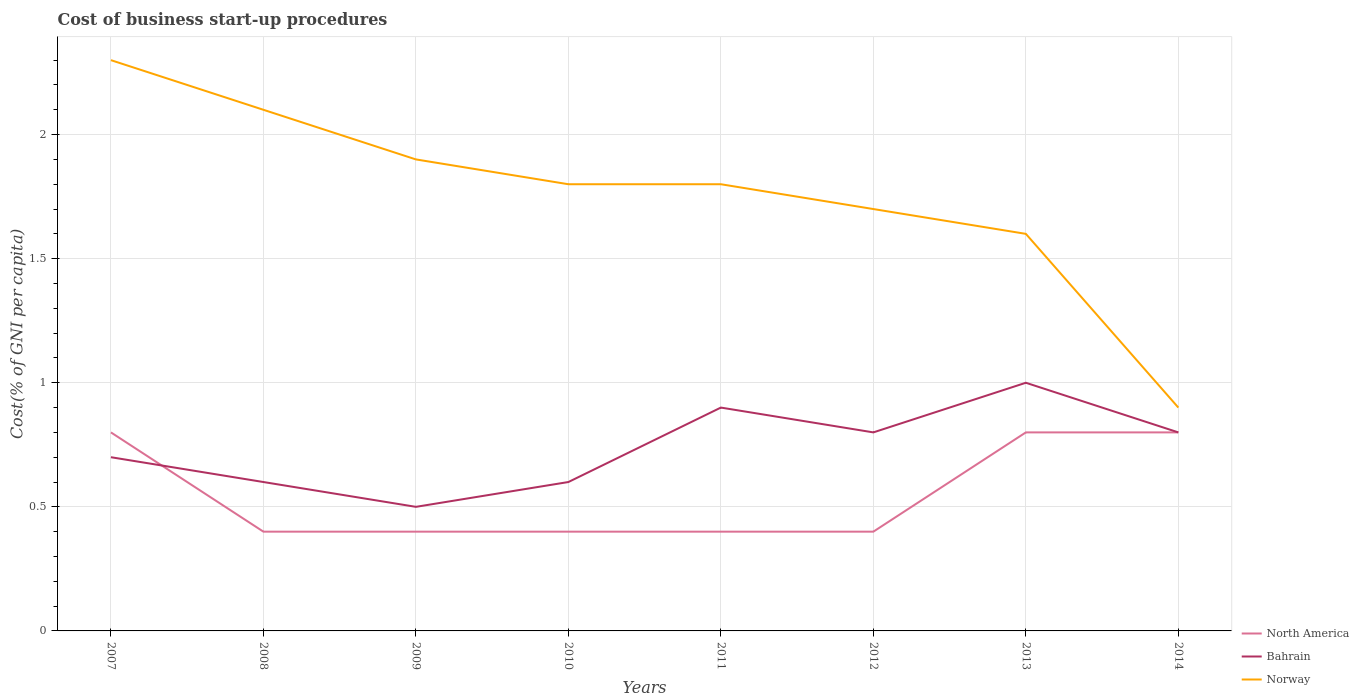Does the line corresponding to Bahrain intersect with the line corresponding to Norway?
Keep it short and to the point. No. What is the total cost of business start-up procedures in Norway in the graph?
Keep it short and to the point. 0.1. What is the difference between the highest and the second highest cost of business start-up procedures in North America?
Ensure brevity in your answer.  0.4. What is the difference between two consecutive major ticks on the Y-axis?
Offer a terse response. 0.5. Does the graph contain grids?
Make the answer very short. Yes. What is the title of the graph?
Offer a terse response. Cost of business start-up procedures. Does "Myanmar" appear as one of the legend labels in the graph?
Your answer should be very brief. No. What is the label or title of the Y-axis?
Offer a terse response. Cost(% of GNI per capita). What is the Cost(% of GNI per capita) in Bahrain in 2007?
Give a very brief answer. 0.7. What is the Cost(% of GNI per capita) in Norway in 2008?
Offer a very short reply. 2.1. What is the Cost(% of GNI per capita) of North America in 2009?
Ensure brevity in your answer.  0.4. What is the Cost(% of GNI per capita) of North America in 2010?
Your answer should be very brief. 0.4. What is the Cost(% of GNI per capita) in Norway in 2010?
Offer a terse response. 1.8. What is the Cost(% of GNI per capita) in North America in 2011?
Offer a very short reply. 0.4. What is the Cost(% of GNI per capita) in Bahrain in 2011?
Offer a very short reply. 0.9. What is the Cost(% of GNI per capita) in Norway in 2012?
Offer a very short reply. 1.7. What is the Cost(% of GNI per capita) of North America in 2013?
Give a very brief answer. 0.8. What is the Cost(% of GNI per capita) in Bahrain in 2013?
Make the answer very short. 1. What is the Cost(% of GNI per capita) of Norway in 2013?
Offer a very short reply. 1.6. What is the Cost(% of GNI per capita) in North America in 2014?
Keep it short and to the point. 0.8. What is the Cost(% of GNI per capita) in Norway in 2014?
Your response must be concise. 0.9. Across all years, what is the maximum Cost(% of GNI per capita) of North America?
Your answer should be compact. 0.8. Across all years, what is the maximum Cost(% of GNI per capita) of Bahrain?
Offer a terse response. 1. Across all years, what is the maximum Cost(% of GNI per capita) of Norway?
Offer a very short reply. 2.3. Across all years, what is the minimum Cost(% of GNI per capita) of Bahrain?
Make the answer very short. 0.5. What is the total Cost(% of GNI per capita) in North America in the graph?
Ensure brevity in your answer.  4.4. What is the total Cost(% of GNI per capita) in Norway in the graph?
Provide a short and direct response. 14.1. What is the difference between the Cost(% of GNI per capita) of Bahrain in 2007 and that in 2009?
Your answer should be very brief. 0.2. What is the difference between the Cost(% of GNI per capita) in Bahrain in 2007 and that in 2010?
Your response must be concise. 0.1. What is the difference between the Cost(% of GNI per capita) of Norway in 2007 and that in 2010?
Keep it short and to the point. 0.5. What is the difference between the Cost(% of GNI per capita) in North America in 2007 and that in 2011?
Give a very brief answer. 0.4. What is the difference between the Cost(% of GNI per capita) in Bahrain in 2007 and that in 2012?
Provide a succinct answer. -0.1. What is the difference between the Cost(% of GNI per capita) of North America in 2007 and that in 2013?
Offer a terse response. 0. What is the difference between the Cost(% of GNI per capita) in Bahrain in 2007 and that in 2013?
Make the answer very short. -0.3. What is the difference between the Cost(% of GNI per capita) of Norway in 2007 and that in 2013?
Provide a succinct answer. 0.7. What is the difference between the Cost(% of GNI per capita) of North America in 2007 and that in 2014?
Offer a very short reply. 0. What is the difference between the Cost(% of GNI per capita) of Norway in 2008 and that in 2009?
Keep it short and to the point. 0.2. What is the difference between the Cost(% of GNI per capita) in Bahrain in 2008 and that in 2010?
Your response must be concise. 0. What is the difference between the Cost(% of GNI per capita) of North America in 2008 and that in 2011?
Give a very brief answer. 0. What is the difference between the Cost(% of GNI per capita) in Bahrain in 2008 and that in 2011?
Offer a terse response. -0.3. What is the difference between the Cost(% of GNI per capita) of North America in 2008 and that in 2012?
Your response must be concise. 0. What is the difference between the Cost(% of GNI per capita) in Bahrain in 2008 and that in 2012?
Provide a succinct answer. -0.2. What is the difference between the Cost(% of GNI per capita) in North America in 2008 and that in 2013?
Ensure brevity in your answer.  -0.4. What is the difference between the Cost(% of GNI per capita) of Norway in 2008 and that in 2014?
Make the answer very short. 1.2. What is the difference between the Cost(% of GNI per capita) in North America in 2009 and that in 2010?
Your response must be concise. 0. What is the difference between the Cost(% of GNI per capita) of North America in 2009 and that in 2011?
Offer a very short reply. 0. What is the difference between the Cost(% of GNI per capita) of North America in 2009 and that in 2012?
Your answer should be compact. 0. What is the difference between the Cost(% of GNI per capita) of Norway in 2009 and that in 2012?
Ensure brevity in your answer.  0.2. What is the difference between the Cost(% of GNI per capita) of Norway in 2009 and that in 2013?
Provide a succinct answer. 0.3. What is the difference between the Cost(% of GNI per capita) of North America in 2009 and that in 2014?
Your response must be concise. -0.4. What is the difference between the Cost(% of GNI per capita) in Bahrain in 2009 and that in 2014?
Your answer should be compact. -0.3. What is the difference between the Cost(% of GNI per capita) in North America in 2010 and that in 2011?
Ensure brevity in your answer.  0. What is the difference between the Cost(% of GNI per capita) in Bahrain in 2010 and that in 2011?
Offer a terse response. -0.3. What is the difference between the Cost(% of GNI per capita) of North America in 2010 and that in 2012?
Ensure brevity in your answer.  0. What is the difference between the Cost(% of GNI per capita) in Bahrain in 2010 and that in 2012?
Your answer should be very brief. -0.2. What is the difference between the Cost(% of GNI per capita) of North America in 2010 and that in 2013?
Offer a very short reply. -0.4. What is the difference between the Cost(% of GNI per capita) of Norway in 2010 and that in 2013?
Your response must be concise. 0.2. What is the difference between the Cost(% of GNI per capita) in North America in 2010 and that in 2014?
Keep it short and to the point. -0.4. What is the difference between the Cost(% of GNI per capita) in Bahrain in 2010 and that in 2014?
Your response must be concise. -0.2. What is the difference between the Cost(% of GNI per capita) in North America in 2011 and that in 2012?
Your response must be concise. 0. What is the difference between the Cost(% of GNI per capita) in Bahrain in 2011 and that in 2012?
Provide a short and direct response. 0.1. What is the difference between the Cost(% of GNI per capita) of Norway in 2011 and that in 2012?
Keep it short and to the point. 0.1. What is the difference between the Cost(% of GNI per capita) in North America in 2011 and that in 2013?
Offer a terse response. -0.4. What is the difference between the Cost(% of GNI per capita) of Bahrain in 2011 and that in 2013?
Make the answer very short. -0.1. What is the difference between the Cost(% of GNI per capita) of Norway in 2011 and that in 2013?
Your answer should be very brief. 0.2. What is the difference between the Cost(% of GNI per capita) in North America in 2011 and that in 2014?
Ensure brevity in your answer.  -0.4. What is the difference between the Cost(% of GNI per capita) of Bahrain in 2011 and that in 2014?
Make the answer very short. 0.1. What is the difference between the Cost(% of GNI per capita) of North America in 2012 and that in 2013?
Keep it short and to the point. -0.4. What is the difference between the Cost(% of GNI per capita) of Norway in 2012 and that in 2013?
Keep it short and to the point. 0.1. What is the difference between the Cost(% of GNI per capita) in Bahrain in 2012 and that in 2014?
Offer a terse response. 0. What is the difference between the Cost(% of GNI per capita) of Norway in 2012 and that in 2014?
Give a very brief answer. 0.8. What is the difference between the Cost(% of GNI per capita) in Norway in 2013 and that in 2014?
Your answer should be very brief. 0.7. What is the difference between the Cost(% of GNI per capita) in North America in 2007 and the Cost(% of GNI per capita) in Norway in 2008?
Your response must be concise. -1.3. What is the difference between the Cost(% of GNI per capita) of North America in 2007 and the Cost(% of GNI per capita) of Bahrain in 2009?
Provide a short and direct response. 0.3. What is the difference between the Cost(% of GNI per capita) of North America in 2007 and the Cost(% of GNI per capita) of Norway in 2009?
Make the answer very short. -1.1. What is the difference between the Cost(% of GNI per capita) in North America in 2007 and the Cost(% of GNI per capita) in Norway in 2011?
Offer a very short reply. -1. What is the difference between the Cost(% of GNI per capita) in North America in 2007 and the Cost(% of GNI per capita) in Bahrain in 2012?
Your answer should be compact. 0. What is the difference between the Cost(% of GNI per capita) of Bahrain in 2007 and the Cost(% of GNI per capita) of Norway in 2013?
Offer a terse response. -0.9. What is the difference between the Cost(% of GNI per capita) of North America in 2007 and the Cost(% of GNI per capita) of Bahrain in 2014?
Offer a very short reply. 0. What is the difference between the Cost(% of GNI per capita) in North America in 2008 and the Cost(% of GNI per capita) in Bahrain in 2009?
Your response must be concise. -0.1. What is the difference between the Cost(% of GNI per capita) of Bahrain in 2008 and the Cost(% of GNI per capita) of Norway in 2009?
Give a very brief answer. -1.3. What is the difference between the Cost(% of GNI per capita) of North America in 2008 and the Cost(% of GNI per capita) of Bahrain in 2012?
Provide a short and direct response. -0.4. What is the difference between the Cost(% of GNI per capita) in Bahrain in 2008 and the Cost(% of GNI per capita) in Norway in 2012?
Ensure brevity in your answer.  -1.1. What is the difference between the Cost(% of GNI per capita) in North America in 2008 and the Cost(% of GNI per capita) in Norway in 2013?
Offer a very short reply. -1.2. What is the difference between the Cost(% of GNI per capita) of Bahrain in 2008 and the Cost(% of GNI per capita) of Norway in 2014?
Offer a very short reply. -0.3. What is the difference between the Cost(% of GNI per capita) of North America in 2009 and the Cost(% of GNI per capita) of Bahrain in 2010?
Offer a terse response. -0.2. What is the difference between the Cost(% of GNI per capita) in North America in 2009 and the Cost(% of GNI per capita) in Norway in 2010?
Offer a terse response. -1.4. What is the difference between the Cost(% of GNI per capita) in North America in 2009 and the Cost(% of GNI per capita) in Bahrain in 2011?
Make the answer very short. -0.5. What is the difference between the Cost(% of GNI per capita) in North America in 2009 and the Cost(% of GNI per capita) in Norway in 2011?
Make the answer very short. -1.4. What is the difference between the Cost(% of GNI per capita) of Bahrain in 2009 and the Cost(% of GNI per capita) of Norway in 2011?
Offer a very short reply. -1.3. What is the difference between the Cost(% of GNI per capita) in Bahrain in 2009 and the Cost(% of GNI per capita) in Norway in 2012?
Provide a short and direct response. -1.2. What is the difference between the Cost(% of GNI per capita) in North America in 2009 and the Cost(% of GNI per capita) in Bahrain in 2013?
Your answer should be very brief. -0.6. What is the difference between the Cost(% of GNI per capita) in North America in 2009 and the Cost(% of GNI per capita) in Norway in 2013?
Offer a terse response. -1.2. What is the difference between the Cost(% of GNI per capita) in Bahrain in 2009 and the Cost(% of GNI per capita) in Norway in 2013?
Provide a succinct answer. -1.1. What is the difference between the Cost(% of GNI per capita) of North America in 2009 and the Cost(% of GNI per capita) of Bahrain in 2014?
Provide a short and direct response. -0.4. What is the difference between the Cost(% of GNI per capita) of Bahrain in 2009 and the Cost(% of GNI per capita) of Norway in 2014?
Keep it short and to the point. -0.4. What is the difference between the Cost(% of GNI per capita) of North America in 2010 and the Cost(% of GNI per capita) of Bahrain in 2011?
Your answer should be very brief. -0.5. What is the difference between the Cost(% of GNI per capita) in North America in 2010 and the Cost(% of GNI per capita) in Bahrain in 2013?
Offer a terse response. -0.6. What is the difference between the Cost(% of GNI per capita) of Bahrain in 2010 and the Cost(% of GNI per capita) of Norway in 2013?
Give a very brief answer. -1. What is the difference between the Cost(% of GNI per capita) of North America in 2010 and the Cost(% of GNI per capita) of Bahrain in 2014?
Keep it short and to the point. -0.4. What is the difference between the Cost(% of GNI per capita) of Bahrain in 2010 and the Cost(% of GNI per capita) of Norway in 2014?
Provide a short and direct response. -0.3. What is the difference between the Cost(% of GNI per capita) of North America in 2011 and the Cost(% of GNI per capita) of Bahrain in 2013?
Ensure brevity in your answer.  -0.6. What is the difference between the Cost(% of GNI per capita) of North America in 2011 and the Cost(% of GNI per capita) of Bahrain in 2014?
Offer a terse response. -0.4. What is the difference between the Cost(% of GNI per capita) in North America in 2012 and the Cost(% of GNI per capita) in Bahrain in 2013?
Provide a succinct answer. -0.6. What is the difference between the Cost(% of GNI per capita) of Bahrain in 2012 and the Cost(% of GNI per capita) of Norway in 2013?
Make the answer very short. -0.8. What is the difference between the Cost(% of GNI per capita) of North America in 2012 and the Cost(% of GNI per capita) of Bahrain in 2014?
Your answer should be very brief. -0.4. What is the difference between the Cost(% of GNI per capita) in North America in 2012 and the Cost(% of GNI per capita) in Norway in 2014?
Ensure brevity in your answer.  -0.5. What is the difference between the Cost(% of GNI per capita) in Bahrain in 2012 and the Cost(% of GNI per capita) in Norway in 2014?
Provide a succinct answer. -0.1. What is the difference between the Cost(% of GNI per capita) in North America in 2013 and the Cost(% of GNI per capita) in Norway in 2014?
Offer a terse response. -0.1. What is the average Cost(% of GNI per capita) in North America per year?
Give a very brief answer. 0.55. What is the average Cost(% of GNI per capita) of Bahrain per year?
Your response must be concise. 0.74. What is the average Cost(% of GNI per capita) in Norway per year?
Your answer should be very brief. 1.76. In the year 2007, what is the difference between the Cost(% of GNI per capita) in North America and Cost(% of GNI per capita) in Norway?
Make the answer very short. -1.5. In the year 2008, what is the difference between the Cost(% of GNI per capita) of North America and Cost(% of GNI per capita) of Bahrain?
Keep it short and to the point. -0.2. In the year 2008, what is the difference between the Cost(% of GNI per capita) of North America and Cost(% of GNI per capita) of Norway?
Give a very brief answer. -1.7. In the year 2008, what is the difference between the Cost(% of GNI per capita) of Bahrain and Cost(% of GNI per capita) of Norway?
Keep it short and to the point. -1.5. In the year 2009, what is the difference between the Cost(% of GNI per capita) in Bahrain and Cost(% of GNI per capita) in Norway?
Keep it short and to the point. -1.4. In the year 2010, what is the difference between the Cost(% of GNI per capita) of North America and Cost(% of GNI per capita) of Bahrain?
Offer a very short reply. -0.2. In the year 2010, what is the difference between the Cost(% of GNI per capita) of North America and Cost(% of GNI per capita) of Norway?
Give a very brief answer. -1.4. In the year 2011, what is the difference between the Cost(% of GNI per capita) of North America and Cost(% of GNI per capita) of Bahrain?
Your answer should be compact. -0.5. In the year 2011, what is the difference between the Cost(% of GNI per capita) in North America and Cost(% of GNI per capita) in Norway?
Give a very brief answer. -1.4. In the year 2011, what is the difference between the Cost(% of GNI per capita) in Bahrain and Cost(% of GNI per capita) in Norway?
Keep it short and to the point. -0.9. In the year 2012, what is the difference between the Cost(% of GNI per capita) of North America and Cost(% of GNI per capita) of Bahrain?
Give a very brief answer. -0.4. In the year 2014, what is the difference between the Cost(% of GNI per capita) of North America and Cost(% of GNI per capita) of Norway?
Offer a terse response. -0.1. In the year 2014, what is the difference between the Cost(% of GNI per capita) of Bahrain and Cost(% of GNI per capita) of Norway?
Provide a succinct answer. -0.1. What is the ratio of the Cost(% of GNI per capita) in Norway in 2007 to that in 2008?
Give a very brief answer. 1.1. What is the ratio of the Cost(% of GNI per capita) in North America in 2007 to that in 2009?
Give a very brief answer. 2. What is the ratio of the Cost(% of GNI per capita) of Norway in 2007 to that in 2009?
Your answer should be very brief. 1.21. What is the ratio of the Cost(% of GNI per capita) in North America in 2007 to that in 2010?
Provide a short and direct response. 2. What is the ratio of the Cost(% of GNI per capita) in Norway in 2007 to that in 2010?
Your answer should be very brief. 1.28. What is the ratio of the Cost(% of GNI per capita) in Norway in 2007 to that in 2011?
Make the answer very short. 1.28. What is the ratio of the Cost(% of GNI per capita) in Norway in 2007 to that in 2012?
Give a very brief answer. 1.35. What is the ratio of the Cost(% of GNI per capita) of North America in 2007 to that in 2013?
Ensure brevity in your answer.  1. What is the ratio of the Cost(% of GNI per capita) of Bahrain in 2007 to that in 2013?
Provide a short and direct response. 0.7. What is the ratio of the Cost(% of GNI per capita) in Norway in 2007 to that in 2013?
Keep it short and to the point. 1.44. What is the ratio of the Cost(% of GNI per capita) in Norway in 2007 to that in 2014?
Give a very brief answer. 2.56. What is the ratio of the Cost(% of GNI per capita) in North America in 2008 to that in 2009?
Ensure brevity in your answer.  1. What is the ratio of the Cost(% of GNI per capita) of Bahrain in 2008 to that in 2009?
Offer a terse response. 1.2. What is the ratio of the Cost(% of GNI per capita) of Norway in 2008 to that in 2009?
Provide a short and direct response. 1.11. What is the ratio of the Cost(% of GNI per capita) in North America in 2008 to that in 2010?
Keep it short and to the point. 1. What is the ratio of the Cost(% of GNI per capita) in Bahrain in 2008 to that in 2011?
Make the answer very short. 0.67. What is the ratio of the Cost(% of GNI per capita) of North America in 2008 to that in 2012?
Offer a terse response. 1. What is the ratio of the Cost(% of GNI per capita) in Norway in 2008 to that in 2012?
Keep it short and to the point. 1.24. What is the ratio of the Cost(% of GNI per capita) of North America in 2008 to that in 2013?
Your response must be concise. 0.5. What is the ratio of the Cost(% of GNI per capita) of Norway in 2008 to that in 2013?
Provide a succinct answer. 1.31. What is the ratio of the Cost(% of GNI per capita) in Norway in 2008 to that in 2014?
Provide a succinct answer. 2.33. What is the ratio of the Cost(% of GNI per capita) in North America in 2009 to that in 2010?
Ensure brevity in your answer.  1. What is the ratio of the Cost(% of GNI per capita) of Bahrain in 2009 to that in 2010?
Ensure brevity in your answer.  0.83. What is the ratio of the Cost(% of GNI per capita) in Norway in 2009 to that in 2010?
Provide a short and direct response. 1.06. What is the ratio of the Cost(% of GNI per capita) in North America in 2009 to that in 2011?
Provide a succinct answer. 1. What is the ratio of the Cost(% of GNI per capita) in Bahrain in 2009 to that in 2011?
Offer a terse response. 0.56. What is the ratio of the Cost(% of GNI per capita) of Norway in 2009 to that in 2011?
Offer a terse response. 1.06. What is the ratio of the Cost(% of GNI per capita) of Bahrain in 2009 to that in 2012?
Your response must be concise. 0.62. What is the ratio of the Cost(% of GNI per capita) in Norway in 2009 to that in 2012?
Keep it short and to the point. 1.12. What is the ratio of the Cost(% of GNI per capita) in North America in 2009 to that in 2013?
Provide a succinct answer. 0.5. What is the ratio of the Cost(% of GNI per capita) of Norway in 2009 to that in 2013?
Offer a terse response. 1.19. What is the ratio of the Cost(% of GNI per capita) in North America in 2009 to that in 2014?
Keep it short and to the point. 0.5. What is the ratio of the Cost(% of GNI per capita) of Bahrain in 2009 to that in 2014?
Your response must be concise. 0.62. What is the ratio of the Cost(% of GNI per capita) of Norway in 2009 to that in 2014?
Your answer should be very brief. 2.11. What is the ratio of the Cost(% of GNI per capita) of Norway in 2010 to that in 2012?
Your answer should be very brief. 1.06. What is the ratio of the Cost(% of GNI per capita) of Bahrain in 2011 to that in 2012?
Keep it short and to the point. 1.12. What is the ratio of the Cost(% of GNI per capita) of Norway in 2011 to that in 2012?
Offer a very short reply. 1.06. What is the ratio of the Cost(% of GNI per capita) of North America in 2011 to that in 2013?
Your answer should be very brief. 0.5. What is the ratio of the Cost(% of GNI per capita) in Bahrain in 2011 to that in 2013?
Make the answer very short. 0.9. What is the ratio of the Cost(% of GNI per capita) in Norway in 2011 to that in 2013?
Your answer should be very brief. 1.12. What is the ratio of the Cost(% of GNI per capita) in North America in 2011 to that in 2014?
Ensure brevity in your answer.  0.5. What is the ratio of the Cost(% of GNI per capita) in Bahrain in 2011 to that in 2014?
Your answer should be compact. 1.12. What is the ratio of the Cost(% of GNI per capita) of Norway in 2011 to that in 2014?
Keep it short and to the point. 2. What is the ratio of the Cost(% of GNI per capita) in Bahrain in 2012 to that in 2013?
Your answer should be compact. 0.8. What is the ratio of the Cost(% of GNI per capita) of Norway in 2012 to that in 2013?
Provide a succinct answer. 1.06. What is the ratio of the Cost(% of GNI per capita) of North America in 2012 to that in 2014?
Keep it short and to the point. 0.5. What is the ratio of the Cost(% of GNI per capita) of Norway in 2012 to that in 2014?
Offer a terse response. 1.89. What is the ratio of the Cost(% of GNI per capita) of North America in 2013 to that in 2014?
Your answer should be very brief. 1. What is the ratio of the Cost(% of GNI per capita) in Norway in 2013 to that in 2014?
Your answer should be compact. 1.78. What is the difference between the highest and the second highest Cost(% of GNI per capita) in Bahrain?
Provide a short and direct response. 0.1. What is the difference between the highest and the second highest Cost(% of GNI per capita) of Norway?
Your answer should be very brief. 0.2. 